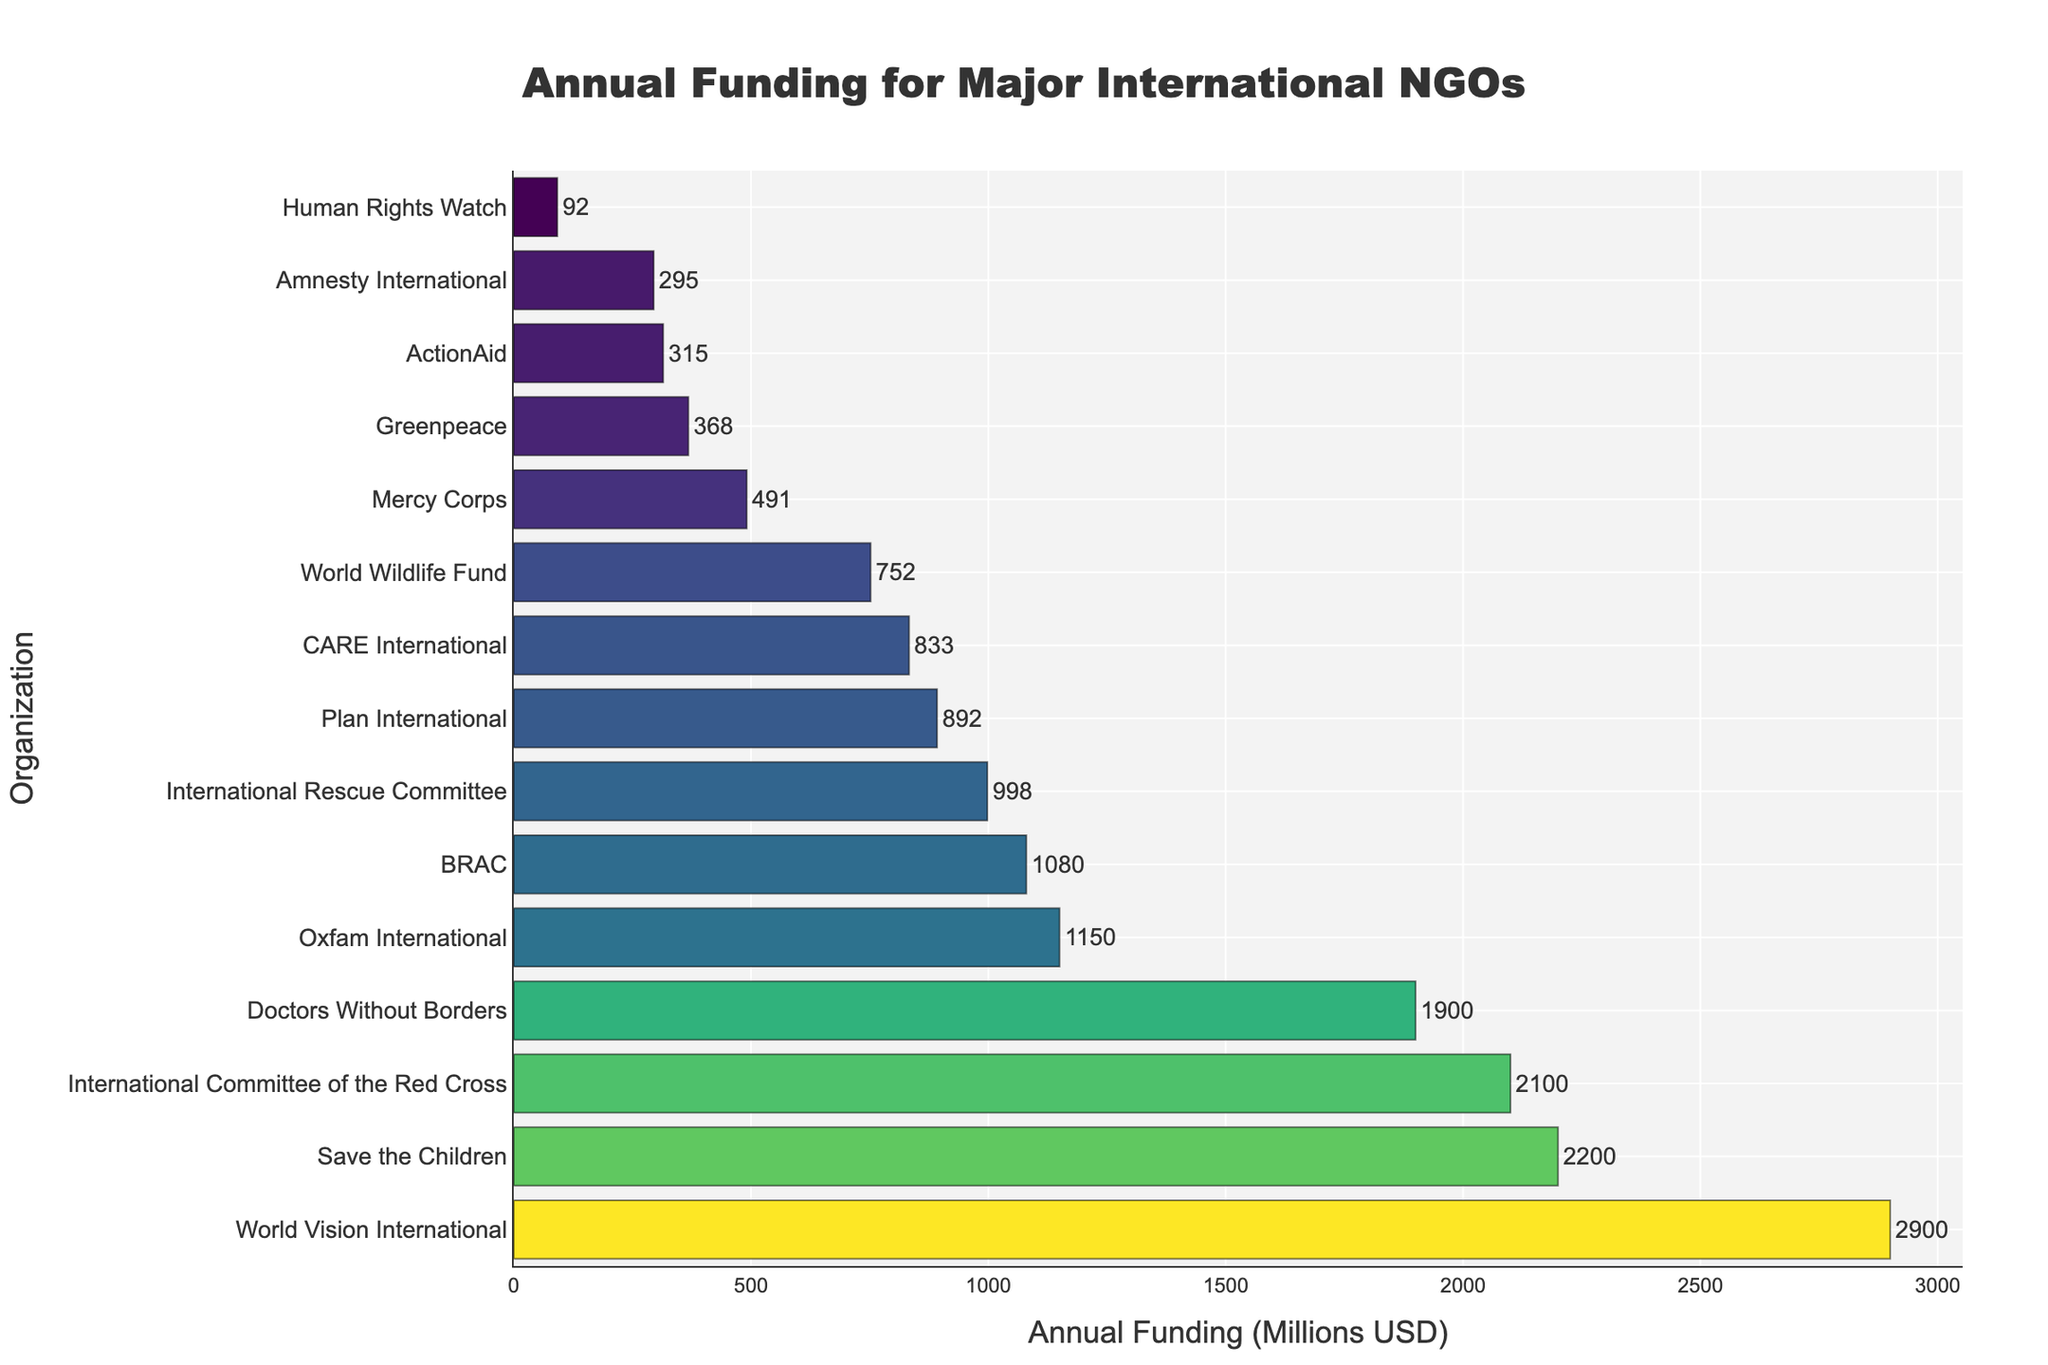Which organization receives the highest annual funding? By visually identifying the bar with the greatest length (rightmost bar on the x-axis), you can determine the organization with the highest annual funding.
Answer: World Vision International Which organization receives the lowest annual funding? By visually identifying the bar with the shortest length (leftmost bar on the x-axis), you can determine the organization with the lowest annual funding.
Answer: Human Rights Watch How much more funding does the International Committee of the Red Cross receive compared to Amnesty International? Subtract the annual funding of Amnesty International from the annual funding of the International Committee of the Red Cross (2100 - 295).
Answer: 1805 million USD What is the average annual funding of the top 5 organizations? Sum the annual funding of the top 5 organizations (2900 + 2200 + 2100 + 1900 + 1150) and divide by 5. The total is 10250, so the average is 10250/5.
Answer: 2050 million USD What is the difference in annual funding between Doctors Without Borders and Save the Children? Subtract the annual funding of Doctors Without Borders from the annual funding of Save the Children (2200 - 1900).
Answer: 300 million USD Which organization ranks 8th in terms of receiving annual funding? By identifying the organization at the 8th position from the top of the sorted list of bars.
Answer: Plan International What is the total annual funding for organizations receiving more than 1000 million USD? Sum the annual funding of organizations receiving more than 1000 million USD: World Vision International (2900), Save the Children (2200), International Committee of the Red Cross (2100), Doctors Without Borders (1900), and Oxfam International (1150). The total is 10250 million USD.
Answer: 10250 million USD How many organizations receive annual funding between 500 and 1000 million USD? Count the number of bars representing organizations within the 500 to 1000 million USD range: Mercy Corps (491), International Rescue Committee (998), Plan International (892), and CARE International (833). Four organizations meet this criterion.
Answer: 4 organizations What percentage difference is there in funding between BRAC and CARE International? Calculate the difference (1080 - 833), then divide by CARE International's funding and multiply by 100: (247 / 833) * 100 ≈ 29.65%.
Answer: Approximately 29.65% 